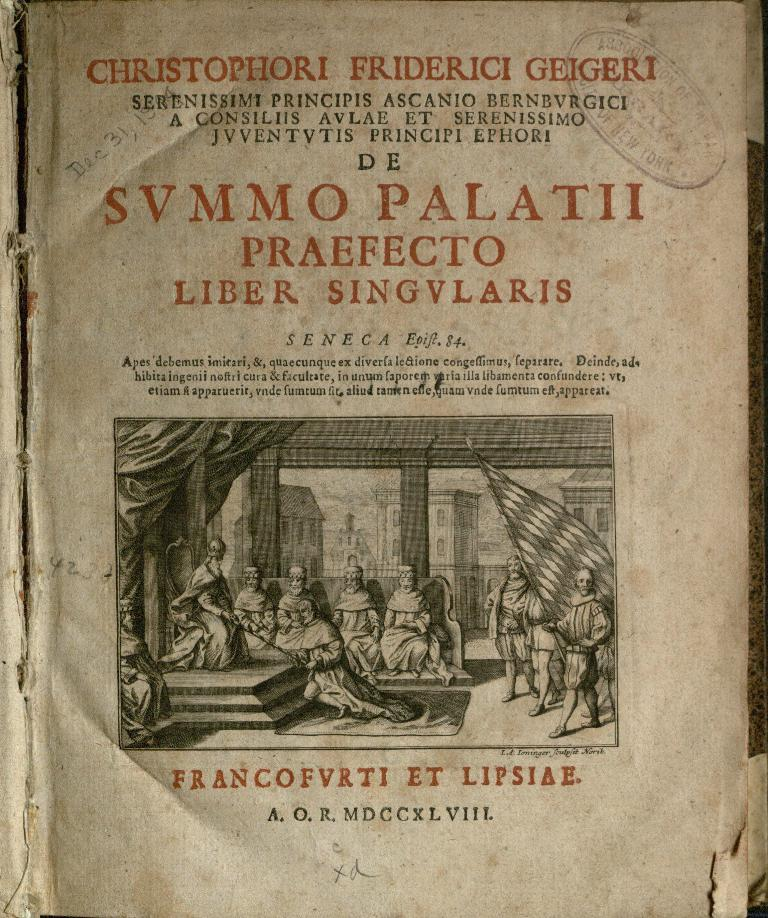<image>
Create a compact narrative representing the image presented. the cover page of a book written in italian with the name francofvrti et lipsiae on the bottom. 